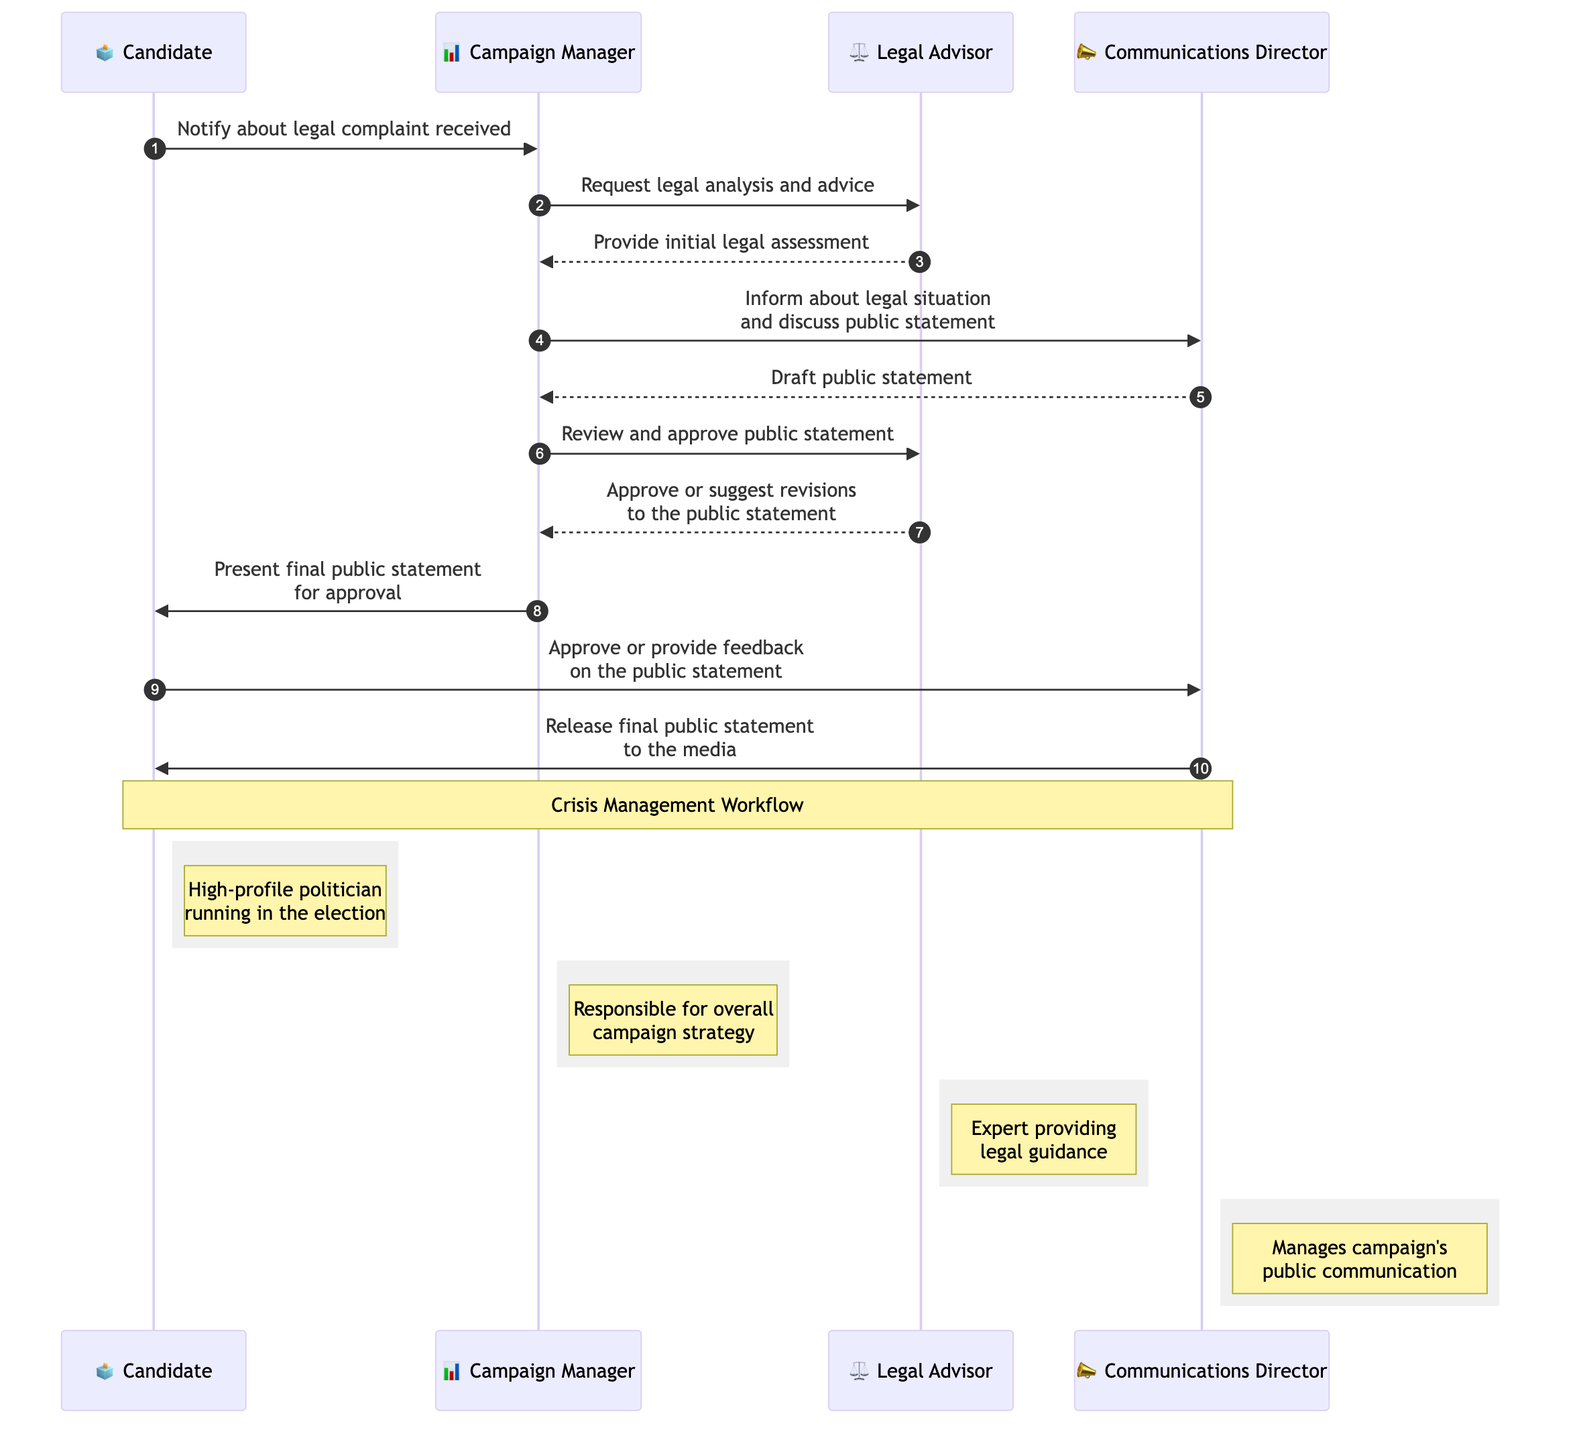What is the first message sent in the sequence? The first message in the sequence is from the Candidate to the Campaign Manager, notifying about the legal complaint received.
Answer: Notify about legal complaint received How many participants are in the sequence diagram? There are four participants: Candidate, Campaign Manager, Legal Advisor, and Communications Director.
Answer: Four Which participant drafts the public statement? The Communications Director is responsible for drafting the public statement based on the information provided by the Campaign Manager.
Answer: Communications Director What is the last action taken in the sequence? The last action in the sequence is the release of the final public statement to the media by the Communications Director.
Answer: Release final public statement to the media Who provides the initial legal assessment? The Legal Advisor provides the initial legal assessment to the Campaign Manager after being requested for legal analysis and advice.
Answer: Legal Advisor What does the Campaign Manager do before presenting the final public statement to the Candidate? The Campaign Manager reviews and approves the public statement before presenting it to the Candidate for approval.
Answer: Review and approve public statement Which participant is notified of the legal situation and public statement discussions? The Campaign Manager informs the Communications Director about the legal situation and discusses the public statement with them.
Answer: Communications Director Before releasing the public statement, which participant provides feedback or approval? The Candidate is the participant who approves or provides feedback on the public statement before it is released.
Answer: Candidate 